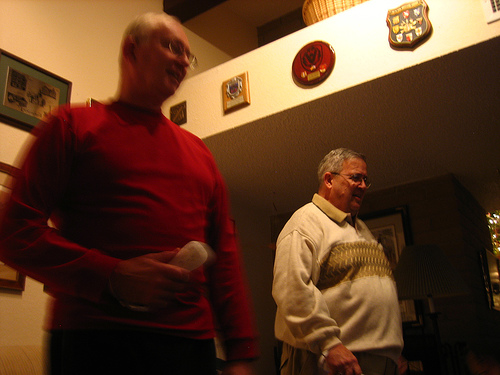Is the shirt below the frame? Yes, the shirt cannot be fully seen in the image as it extends below the visible frame. 